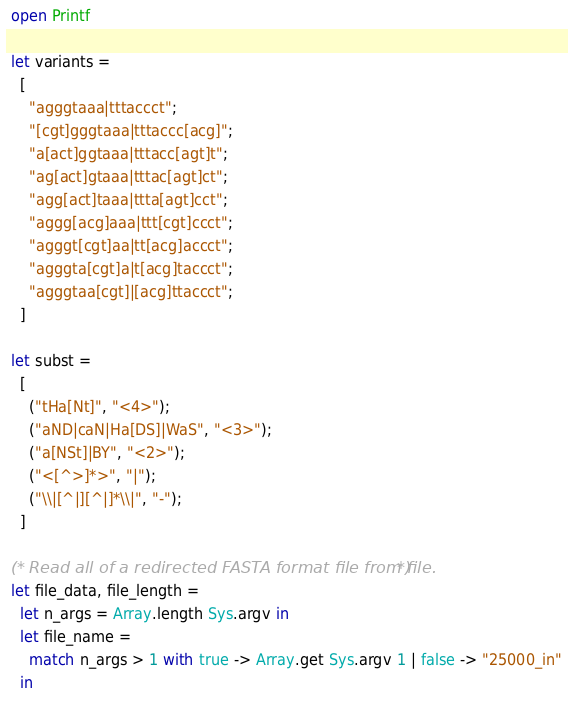Convert code to text. <code><loc_0><loc_0><loc_500><loc_500><_OCaml_>
 open Printf

 let variants =
   [
     "agggtaaa|tttaccct";
     "[cgt]gggtaaa|tttaccc[acg]";
     "a[act]ggtaaa|tttacc[agt]t";
     "ag[act]gtaaa|tttac[agt]ct";
     "agg[act]taaa|ttta[agt]cct";
     "aggg[acg]aaa|ttt[cgt]ccct";
     "agggt[cgt]aa|tt[acg]accct";
     "agggta[cgt]a|t[acg]taccct";
     "agggtaa[cgt]|[acg]ttaccct";
   ]
 
 let subst =
   [
     ("tHa[Nt]", "<4>");
     ("aND|caN|Ha[DS]|WaS", "<3>");
     ("a[NSt]|BY", "<2>");
     ("<[^>]*>", "|");
     ("\\|[^|][^|]*\\|", "-");
   ]
 
 (* Read all of a redirected FASTA format file from file. *)
 let file_data, file_length =
   let n_args = Array.length Sys.argv in
   let file_name =
     match n_args > 1 with true -> Array.get Sys.argv 1 | false -> "25000_in"
   in</code> 